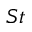Convert formula to latex. <formula><loc_0><loc_0><loc_500><loc_500>S t</formula> 